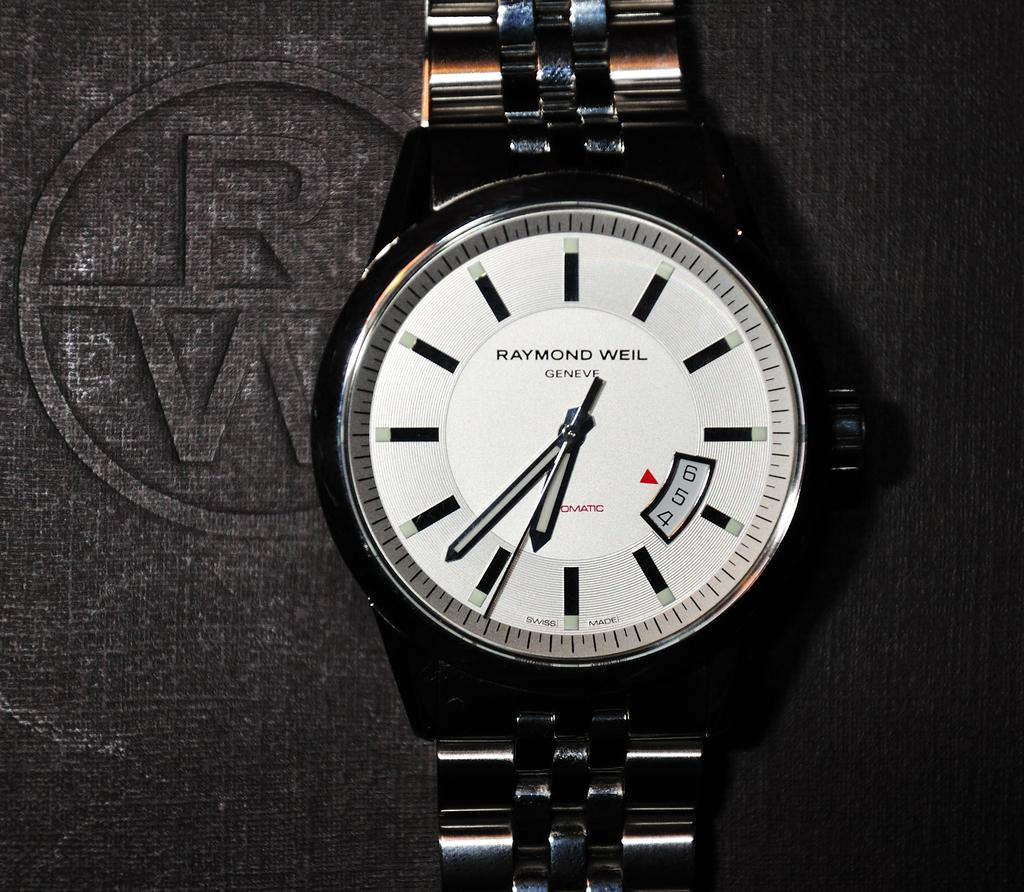<image>
Write a terse but informative summary of the picture. A Raymond Weil watch reads six thirty eight. 